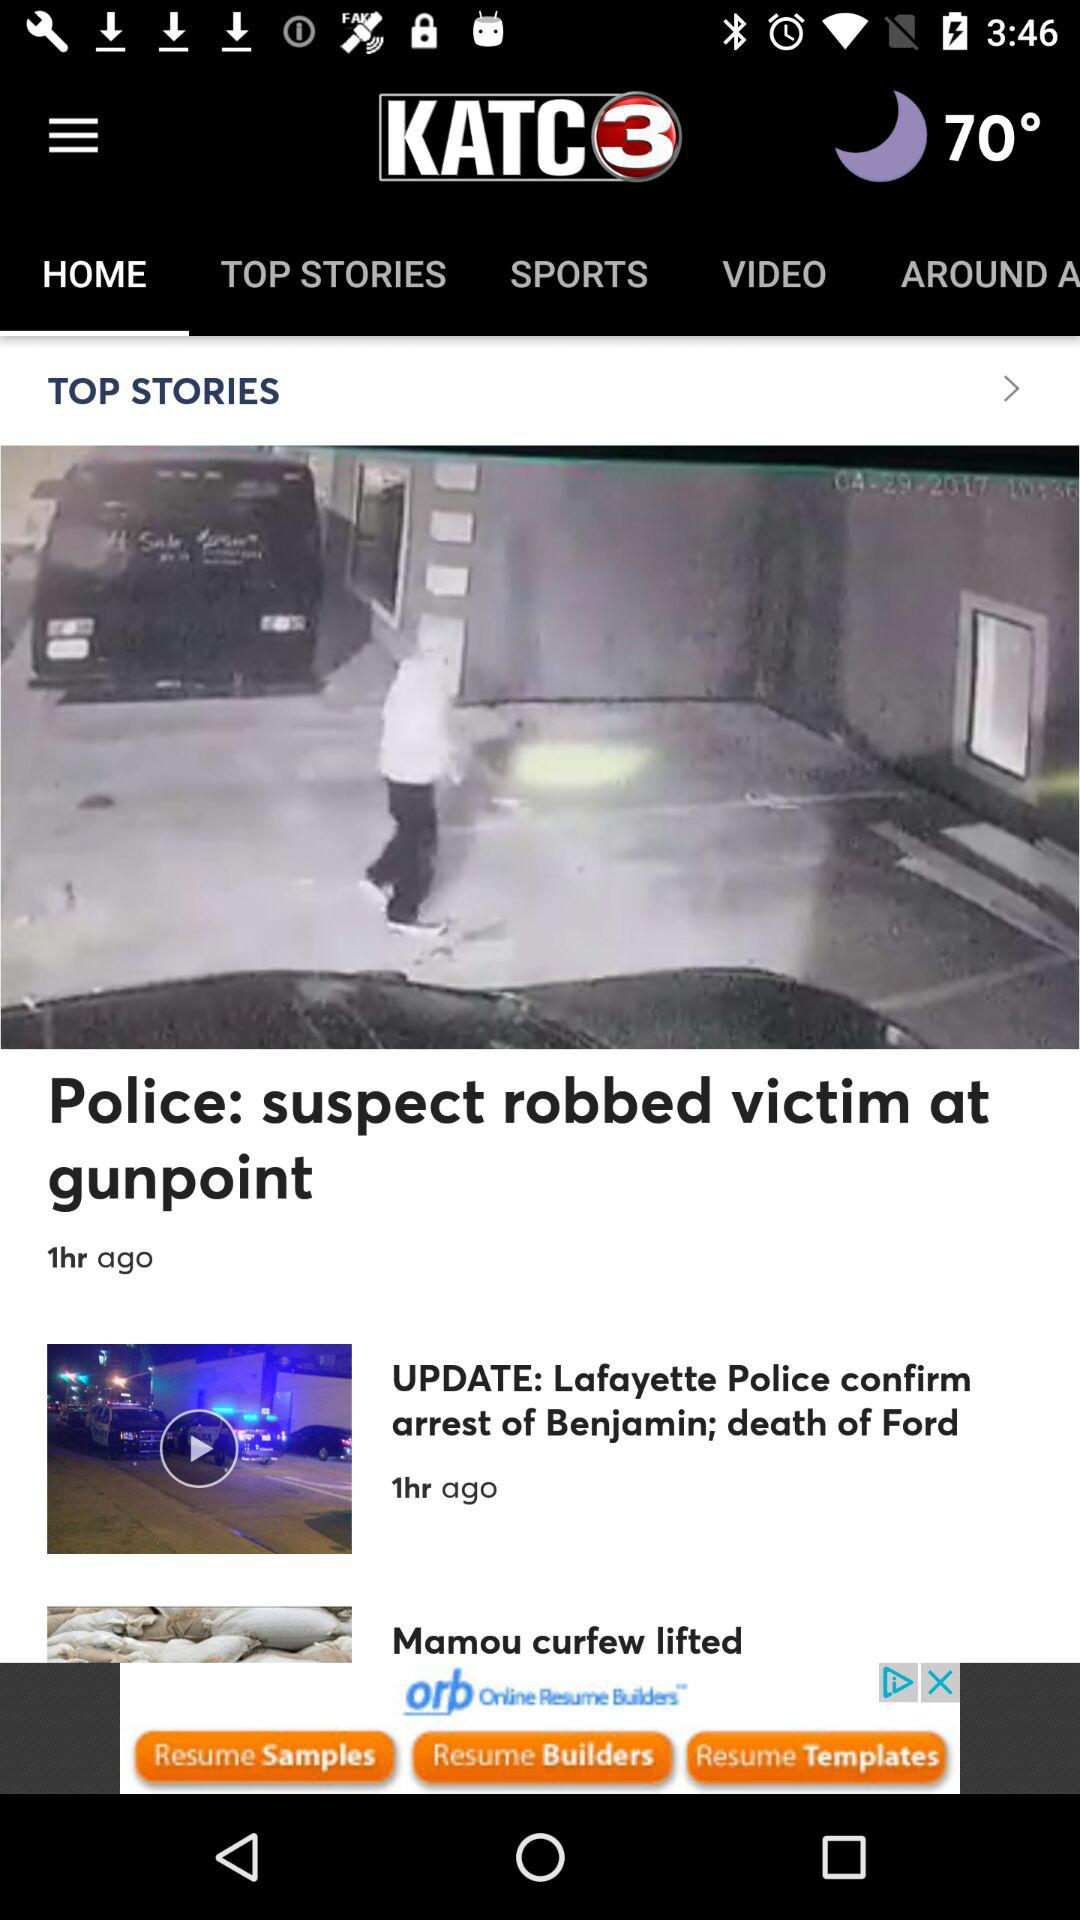What is the temperature? The temperature is 70°. 